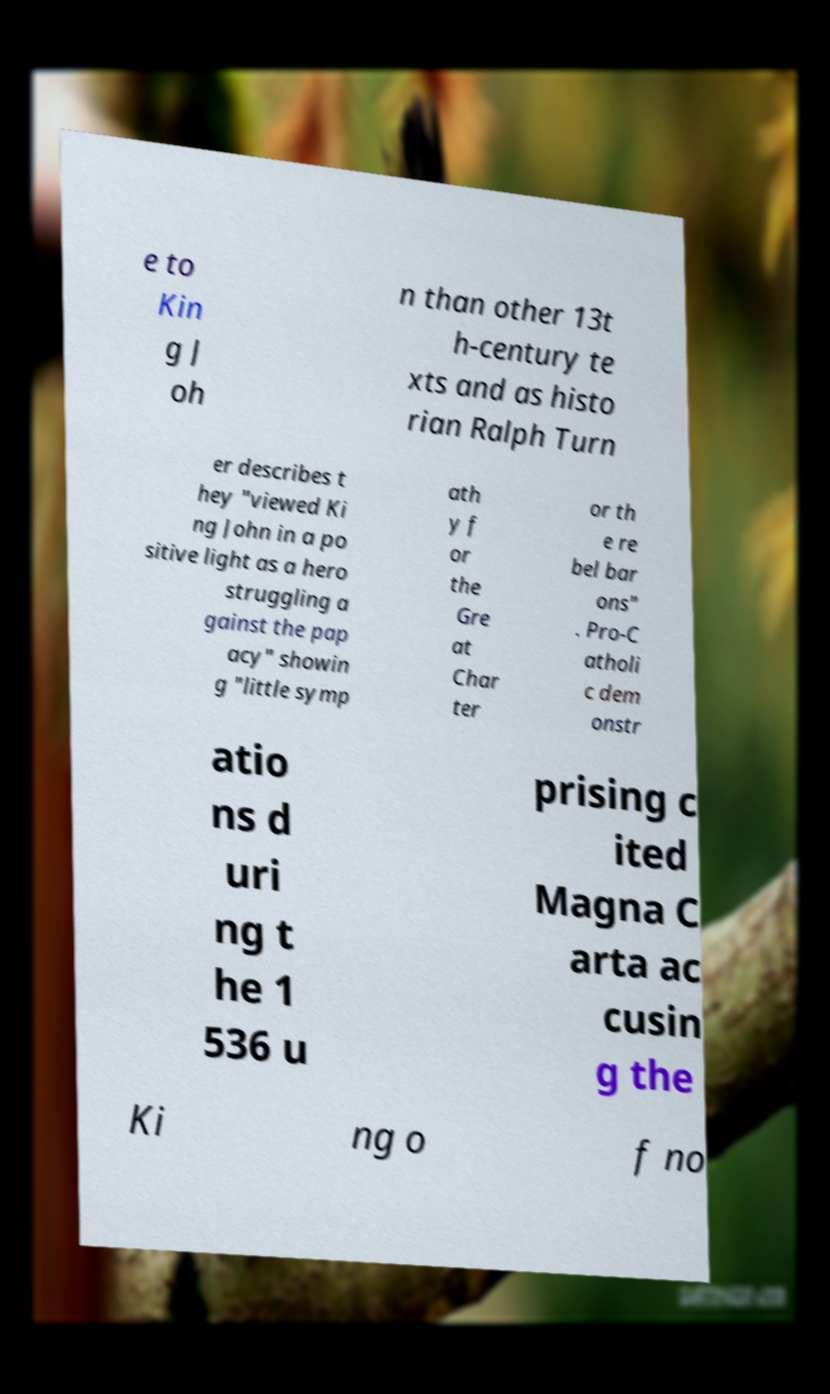There's text embedded in this image that I need extracted. Can you transcribe it verbatim? e to Kin g J oh n than other 13t h-century te xts and as histo rian Ralph Turn er describes t hey "viewed Ki ng John in a po sitive light as a hero struggling a gainst the pap acy" showin g "little symp ath y f or the Gre at Char ter or th e re bel bar ons" . Pro-C atholi c dem onstr atio ns d uri ng t he 1 536 u prising c ited Magna C arta ac cusin g the Ki ng o f no 